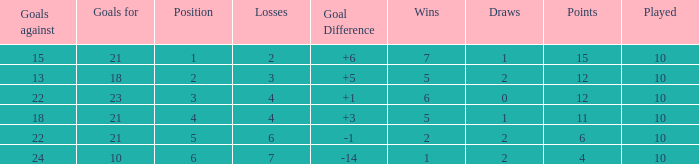Can you tell me the lowest Played that has the Position larger than 2, and the Draws smaller than 2, and the Goals against smaller than 18? None. 